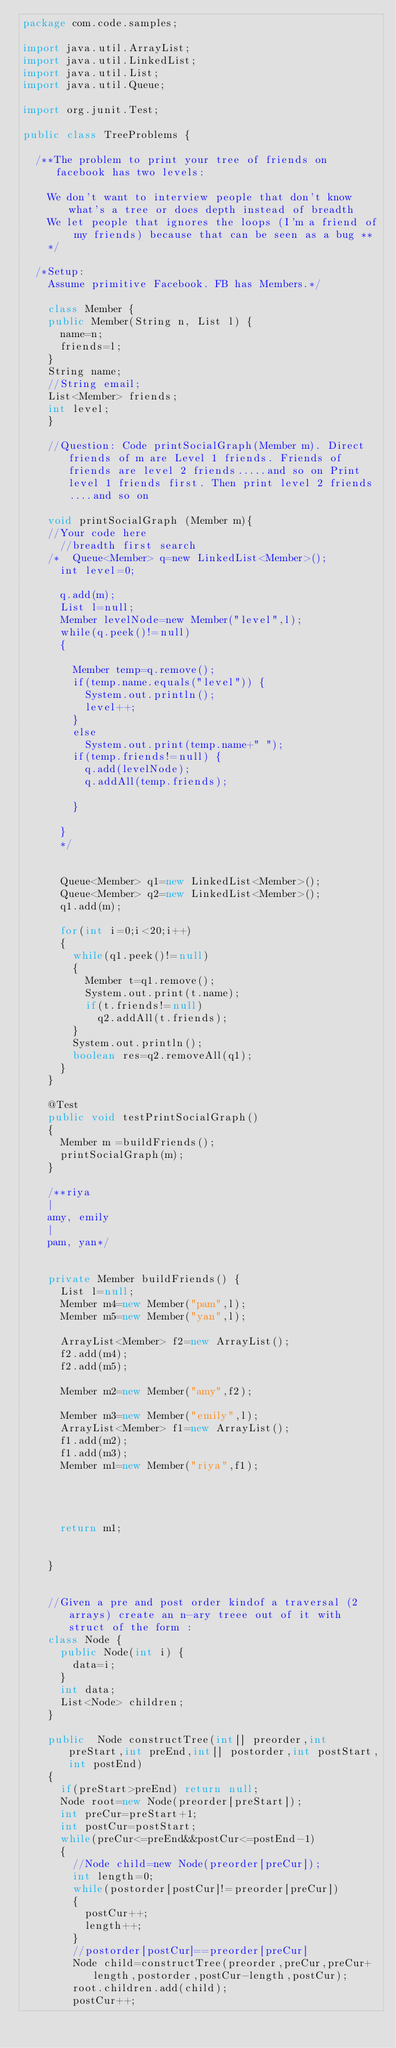Convert code to text. <code><loc_0><loc_0><loc_500><loc_500><_Java_>package com.code.samples;

import java.util.ArrayList;
import java.util.LinkedList;
import java.util.List;
import java.util.Queue;

import org.junit.Test;

public class TreeProblems {

	/**The problem to print your tree of friends on facebook has two levels:

    We don't want to interview people that don't know what's a tree or does depth instead of breadth
    We let people that ignores the loops (I'm a friend of my friends) because that can be seen as a bug **
    */
	
	/*Setup:
		Assume primitive Facebook. FB has Members.*/

		class Member {
		public Member(String n, List l) {
			name=n;
			friends=l;
		}
		String name;
		//String email;
		List<Member> friends;
		int level;
		}

		//Question: Code printSocialGraph(Member m). Direct friends of m are Level 1 friends. Friends of friends are level 2 friends.....and so on Print level 1 friends first. Then print level 2 friends....and so on

		void printSocialGraph (Member m){
		//Your code here
			//breadth first search
		/*	Queue<Member> q=new LinkedList<Member>();
			int level=0;
			
			q.add(m);
			List l=null;
			Member levelNode=new Member("level",l);
			while(q.peek()!=null)
			{
				
				Member temp=q.remove();
				if(temp.name.equals("level")) {
					System.out.println();
					level++;
				}
				else
					System.out.print(temp.name+" ");
				if(temp.friends!=null) {
					q.add(levelNode);
					q.addAll(temp.friends);
				
				}
				
			}
			*/
		
			
			Queue<Member> q1=new LinkedList<Member>();
			Queue<Member> q2=new LinkedList<Member>();
			q1.add(m);
			
			for(int i=0;i<20;i++)
			{
				while(q1.peek()!=null)
				{
					Member t=q1.remove();
					System.out.print(t.name);
					if(t.friends!=null)
						q2.addAll(t.friends);			
				}
				System.out.println();
				boolean res=q2.removeAll(q1);
			}
		}

		@Test
		public void testPrintSocialGraph()
		{
			Member m =buildFriends();
			printSocialGraph(m);
		}
		
		/**riya
		|
		amy, emily
		|
		pam, yan*/


		private Member buildFriends() {
			List l=null;
			Member m4=new Member("pam",l);
			Member m5=new Member("yan",l);
			
			ArrayList<Member> f2=new ArrayList();
			f2.add(m4);
			f2.add(m5);
			
			Member m2=new Member("amy",f2);

			Member m3=new Member("emily",l);
			ArrayList<Member> f1=new ArrayList();
			f1.add(m2);
			f1.add(m3);
			Member m1=new Member("riya",f1);
			
			
			

			return m1;
			
			
		}
		
		
		//Given a pre and post order kindof a traversal (2 arrays) create an n-ary treee out of it with struct of the form :
		class Node {
			public Node(int i) {
				data=i;
			}
			int data;
			List<Node> children;
		}
			
		public  Node constructTree(int[] preorder,int preStart,int preEnd,int[] postorder,int postStart,int postEnd)
		{
			if(preStart>preEnd) return null;
			Node root=new Node(preorder[preStart]);
			int preCur=preStart+1;
			int postCur=postStart;
			while(preCur<=preEnd&&postCur<=postEnd-1)
			{
				//Node child=new Node(preorder[preCur]);
				int length=0;
				while(postorder[postCur]!=preorder[preCur])
				{
					postCur++;
					length++;
				}
				//postorder[postCur]==preorder[preCur]
				Node child=constructTree(preorder,preCur,preCur+length,postorder,postCur-length,postCur);
				root.children.add(child);
				postCur++;</code> 